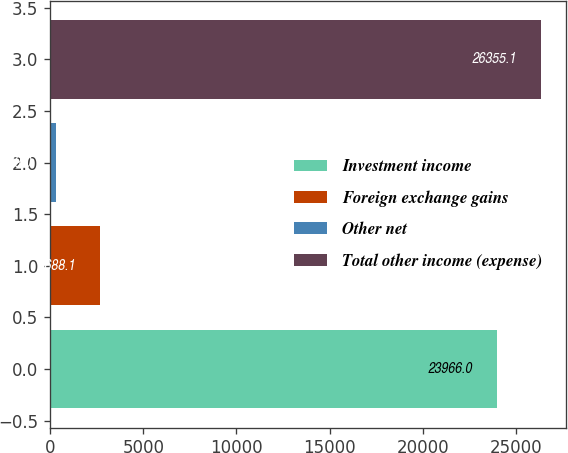Convert chart. <chart><loc_0><loc_0><loc_500><loc_500><bar_chart><fcel>Investment income<fcel>Foreign exchange gains<fcel>Other net<fcel>Total other income (expense)<nl><fcel>23966<fcel>2688.1<fcel>299<fcel>26355.1<nl></chart> 